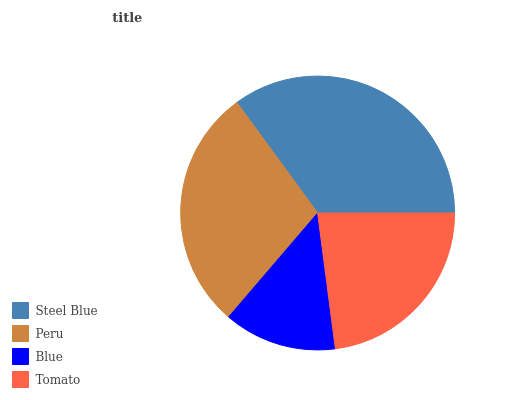Is Blue the minimum?
Answer yes or no. Yes. Is Steel Blue the maximum?
Answer yes or no. Yes. Is Peru the minimum?
Answer yes or no. No. Is Peru the maximum?
Answer yes or no. No. Is Steel Blue greater than Peru?
Answer yes or no. Yes. Is Peru less than Steel Blue?
Answer yes or no. Yes. Is Peru greater than Steel Blue?
Answer yes or no. No. Is Steel Blue less than Peru?
Answer yes or no. No. Is Peru the high median?
Answer yes or no. Yes. Is Tomato the low median?
Answer yes or no. Yes. Is Blue the high median?
Answer yes or no. No. Is Steel Blue the low median?
Answer yes or no. No. 